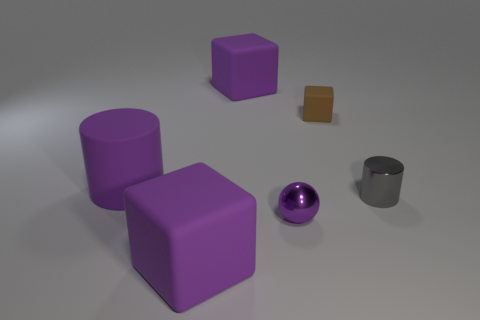How many other things are the same size as the purple metal thing?
Keep it short and to the point. 2. There is a large purple rubber cylinder; how many purple matte blocks are behind it?
Offer a very short reply. 1. What is the size of the brown object?
Offer a terse response. Small. Is the cylinder that is on the left side of the tiny purple shiny object made of the same material as the purple ball right of the large rubber cylinder?
Give a very brief answer. No. Are there any big things of the same color as the metallic ball?
Your answer should be very brief. Yes. There is a cylinder that is the same size as the brown rubber block; what is its color?
Your answer should be compact. Gray. Do the big thing that is in front of the rubber cylinder and the tiny sphere have the same color?
Offer a very short reply. Yes. Are there any blue cylinders that have the same material as the small sphere?
Ensure brevity in your answer.  No. What is the shape of the tiny thing that is the same color as the large rubber cylinder?
Keep it short and to the point. Sphere. Are there fewer purple spheres behind the brown cube than big purple objects?
Offer a terse response. Yes. 